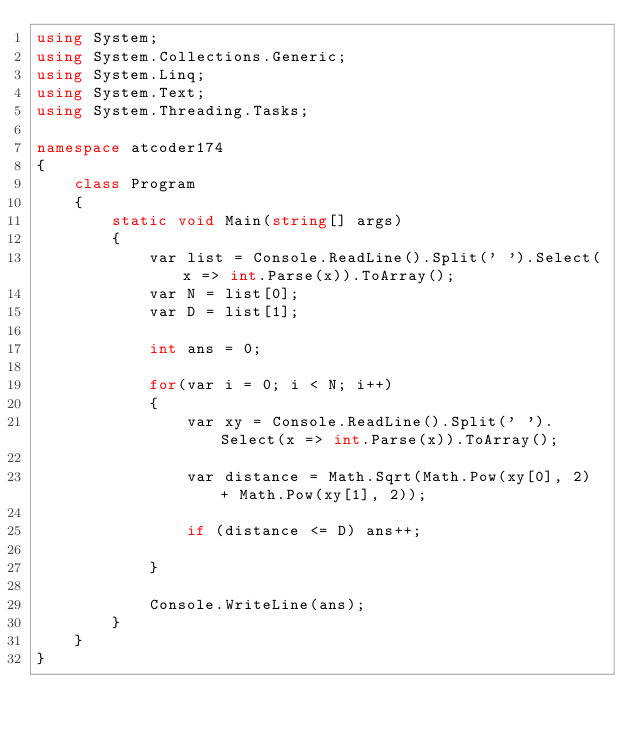Convert code to text. <code><loc_0><loc_0><loc_500><loc_500><_C#_>using System;
using System.Collections.Generic;
using System.Linq;
using System.Text;
using System.Threading.Tasks;

namespace atcoder174
{
    class Program
    {
        static void Main(string[] args)
        {
            var list = Console.ReadLine().Split(' ').Select(x => int.Parse(x)).ToArray();
            var N = list[0];
            var D = list[1];

            int ans = 0;

            for(var i = 0; i < N; i++)
            {
                var xy = Console.ReadLine().Split(' ').Select(x => int.Parse(x)).ToArray();

                var distance = Math.Sqrt(Math.Pow(xy[0], 2) + Math.Pow(xy[1], 2));

                if (distance <= D) ans++;

            }

            Console.WriteLine(ans);
        }
    }
}
</code> 